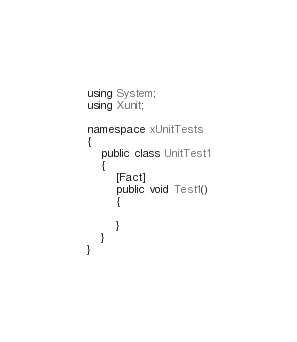<code> <loc_0><loc_0><loc_500><loc_500><_C#_>using System;
using Xunit;

namespace xUnitTests
{
    public class UnitTest1
    {
        [Fact]
        public void Test1()
        {

        }
    }
}
</code> 